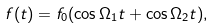Convert formula to latex. <formula><loc_0><loc_0><loc_500><loc_500>f ( t ) = f _ { 0 } ( \cos { \Omega _ { 1 } t } + \cos { \Omega _ { 2 } t } ) ,</formula> 